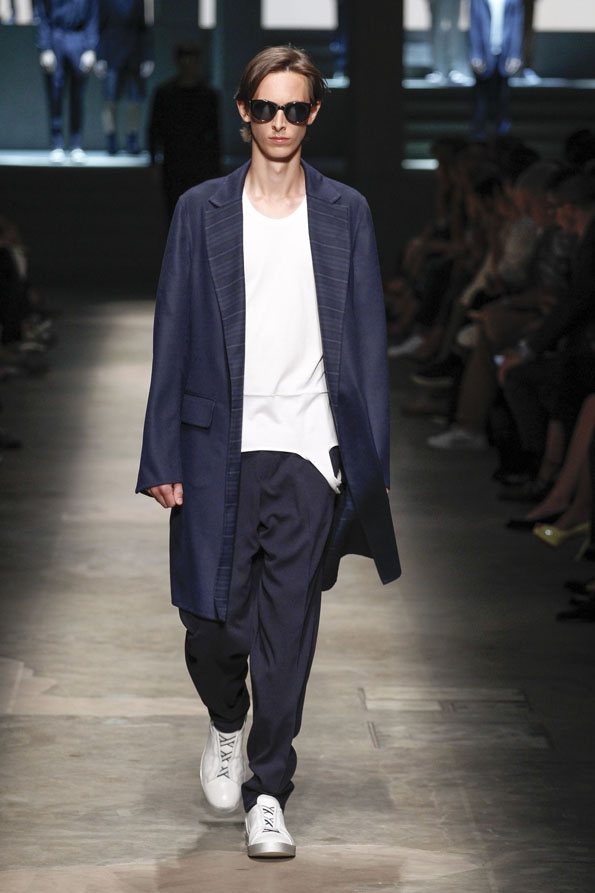Create a scenario where this outfit is part of a high-stakes heist team uniform. In an intricately planned high-stakes heist, this outfit serves as the uniform for the team's 'Infiltrator' – a role that requires blending into high society while maintaining agility. The sleek navy coat is lined with hidden pockets for essential tools, and its oversized nature allows for movement without restriction. The minimalistic white t-shirt and loose trousers further enable swift, unobstructed actions, whether scaling walls or navigating through laser tripwires. The white sneakers are lightweight and designed for silent movements, integrating advanced grip technology for various terrains. The dark sunglasses serve a dual purpose: concealing identity and incorporating augmented reality displays for real-time updates on security systems and team locations. This uniform combines a facade of sophistication with covert functionality, crucial for the success of the heist. 
How might the outfit be perceived in a casual, everyday setting? In a casual, everyday setting, this outfit would likely be perceived as stylishly effortless. The oversized navy coat adds a touch of elegance and can be seen as a versatile wardrobe staple perfect for both relaxed and semi-formal occasions. The simple white t-shirt and loose trousers suggest comfort and practicality, ideal for daily wear. Paired with white sneakers, the look remains trendy and suitable for a variety of activities, from running errands to meeting friends for a casual lunch. The dark sunglasses contribute a cool, laid-back vibe, completing an ensemble that is both well-coordinated and easygoing. 